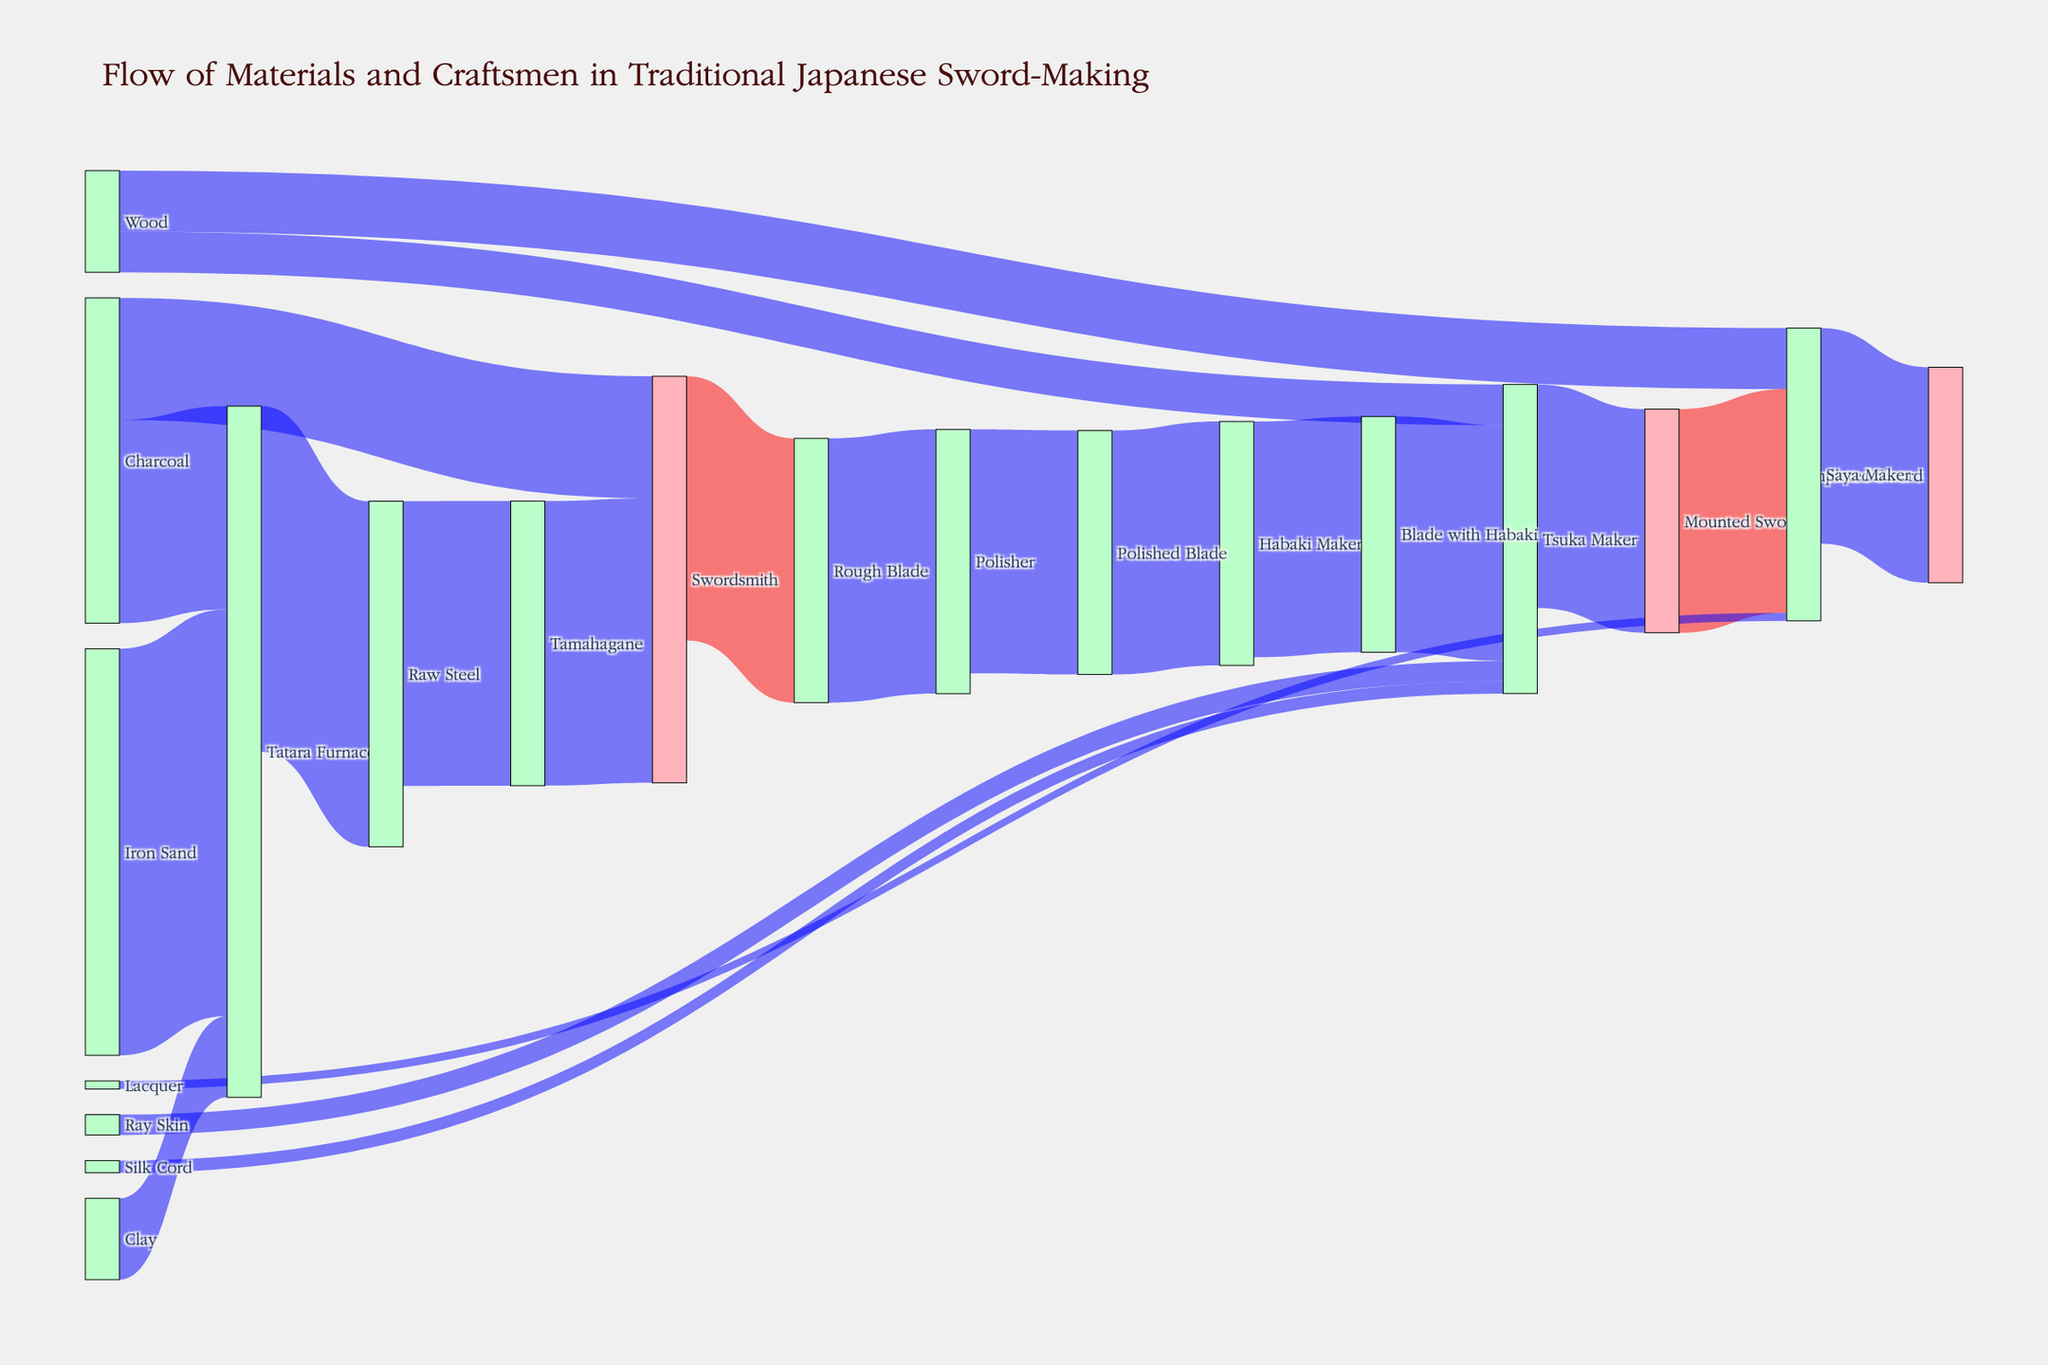What's the title of the figure? The title is usually displayed at the top of the figure, providing a brief description of the content. In this case, it reads "Flow of Materials and Craftsmen in Traditional Japanese Sword-Making".
Answer: Flow of Materials and Craftsmen in Traditional Japanese Sword-Making Which material has the highest value entering the Tatara Furnace? The Sankey diagram shows multiple materials flowing into the Tatara Furnace. By inspecting these flows, the material with the largest value is Iron Sand with a value of 100.
Answer: Iron Sand How many craftsmen are shown in the diagram? Craftsmen can be identified by their roles in the process, such as Swordsmith, Polisher, Habaki Maker, Tsuka Maker, and Saya Maker. By counting these unique roles, we find five craftsmen.
Answer: 5 What is the total value of materials handled by the Tsuka Maker? The Tsuka Maker handles Ray Skin (5), Wood (10), and Silk Cord (3) directly, as well as the Blade with Habaki (58). Summing these values gives 5 + 10 + 3 + 58 = 76.
Answer: 76 From which source does the Swordsmith receive materials? The Swordsmith receives materials from Tamahagane, with a value of 70, and from Charcoal, with a value of 30.
Answer: Tamahagane and Charcoal What is the difference in value between the Polished Blade and the Completed Sword? The value of the Polished Blade is 60, and the value of the Completed Sword is 53. The difference between them is 60 - 53 = 7.
Answer: 7 Which stage in the process has the least value input, and what is the value? The stage with the least value input can be determined by comparing inputs at each stage. Lacquer flows to the Saya Maker with the lowest value of 2.
Answer: Saya Maker, 2 What is the color and format used to represent the flow from Iron Sand to Tatara Furnace? The flow from Iron Sand to Tatara Furnace is colored in a semi-transparent red, evident from the color assignments based on sources containing "Sword".
Answer: semi-transparent red Is there any material that is used in multiple stages of the sword-making process? Both Wood and Charcoal are used in more than one stage. Wood is used by both the Tsuka Maker and Saya Maker, and Charcoal is used by the Tatara Furnace and Swordsmith.
Answer: Wood and Charcoal Which craftsman converts the Rough Blade to the next stage, and what stage is that? The craftsman Polisher converts the Rough Blade to the Polished Blade.
Answer: Polisher, Polished Blade 